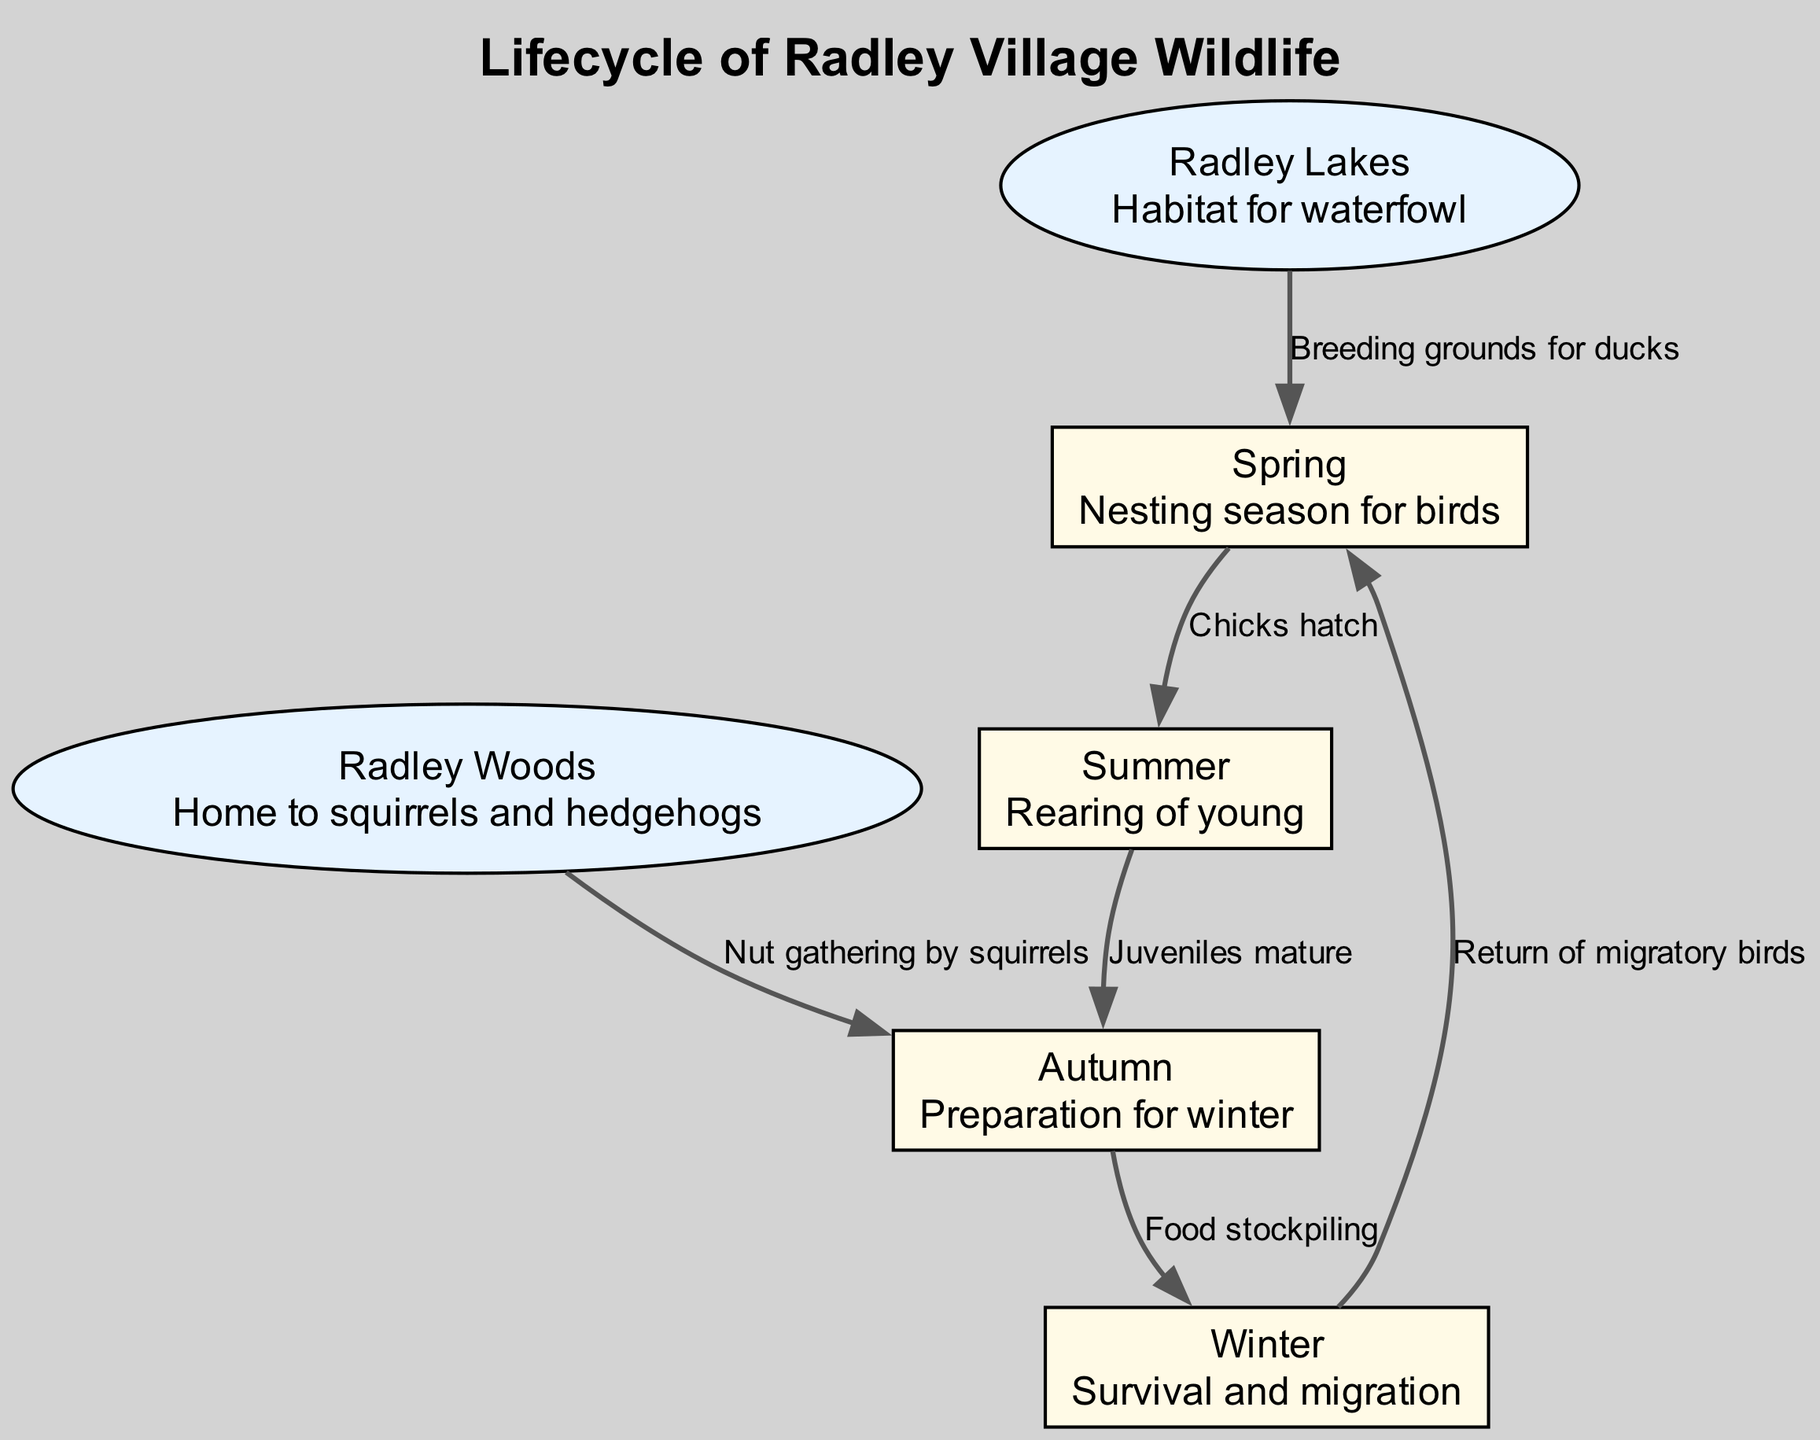What is the starting season for the lifecycle? The diagram indicates that the lifecycle of the local wildlife begins in the Spring, which is labeled as the first node in the sequence.
Answer: Spring How many seasonal stages are present in the diagram? The diagram features four seasonal stages: Spring, Summer, Autumn, and Winter. These can be counted as nodes 1 through 4.
Answer: Four What happens during Summer? According to the diagram, during the Summer, the focus is on the rearing of young wildlife, particularly the growth of juveniles as indicated by the description of node 2.
Answer: Rearing of young What describes the relationship between Spring and Summer? The relationship from Spring to Summer is characterized by the event labeled "Chicks hatch," showcasing the transition from nesting to breeding.
Answer: Chicks hatch Which habitat is associated with waterfowl? The diagram specifies that Radley Lakes serves as the habitat for waterfowl, which is indicated in node 5 along with its description.
Answer: Radley Lakes What activity do squirrels engage in during Autumn? The diagram illustrates that squirrels engage in nut gathering during Autumn, which corresponds to the actions described in the edges linked to Autumn.
Answer: Nut gathering How do migratory birds return in the lifecycle? The diagram demonstrates that migratory birds return in the Winter, represented by the edge from Winter back to Spring labeled "Return of migratory birds."
Answer: Return of migratory birds What is the primary activity of squirrels before Winter? As shown in the connections within the diagram, the primary activity of squirrels before Winter is nut gathering, ensuring they have sufficient food stored.
Answer: Nut gathering How does the lifecycle conclude for birds? The lifecycle concludes for birds with their migration during Winter, as indicated by the edge connecting Winter back to Spring, where they begin nesting again.
Answer: Migration 